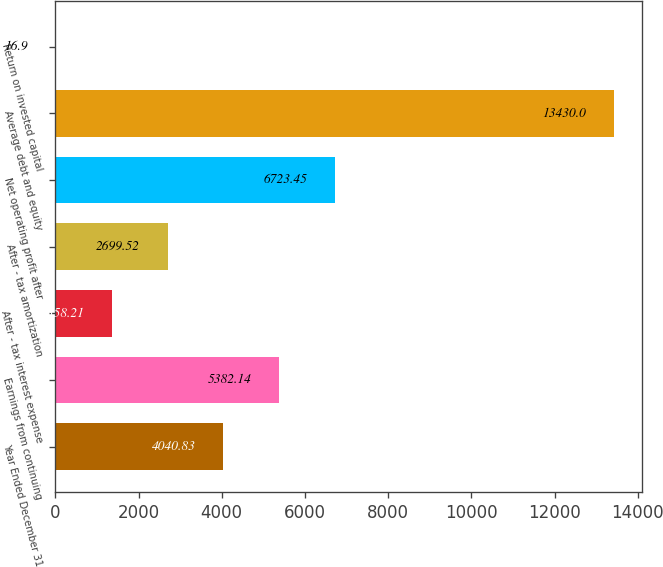Convert chart. <chart><loc_0><loc_0><loc_500><loc_500><bar_chart><fcel>Year Ended December 31<fcel>Earnings from continuing<fcel>After - tax interest expense<fcel>After - tax amortization<fcel>Net operating profit after<fcel>Average debt and equity<fcel>Return on invested capital<nl><fcel>4040.83<fcel>5382.14<fcel>1358.21<fcel>2699.52<fcel>6723.45<fcel>13430<fcel>16.9<nl></chart> 